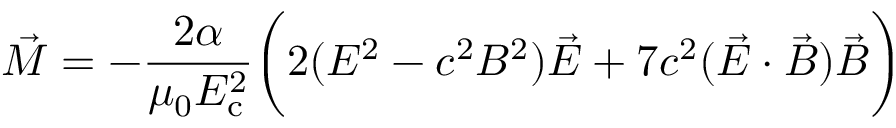<formula> <loc_0><loc_0><loc_500><loc_500>{ \vec { M } } = - { \frac { 2 \alpha } { \mu _ { 0 } E _ { c } ^ { 2 } } } { \left ( } 2 ( E ^ { 2 } - c ^ { 2 } B ^ { 2 } ) { \vec { E } } + 7 c ^ { 2 } ( { \vec { E } } \cdot { \vec { B } } ) { \vec { B } } { \right ) }</formula> 